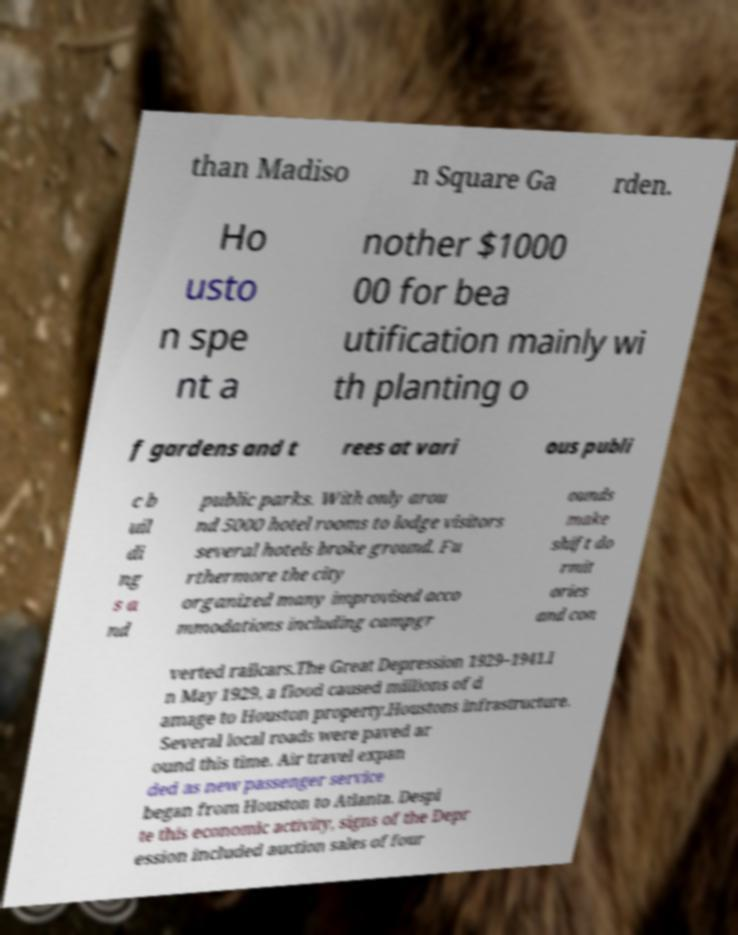Could you extract and type out the text from this image? than Madiso n Square Ga rden. Ho usto n spe nt a nother $1000 00 for bea utification mainly wi th planting o f gardens and t rees at vari ous publi c b uil di ng s a nd public parks. With only arou nd 5000 hotel rooms to lodge visitors several hotels broke ground. Fu rthermore the city organized many improvised acco mmodations including campgr ounds make shift do rmit ories and con verted railcars.The Great Depression 1929–1941.I n May 1929, a flood caused millions of d amage to Houston property.Houstons infrastructure. Several local roads were paved ar ound this time. Air travel expan ded as new passenger service began from Houston to Atlanta. Despi te this economic activity, signs of the Depr ession included auction sales of four 